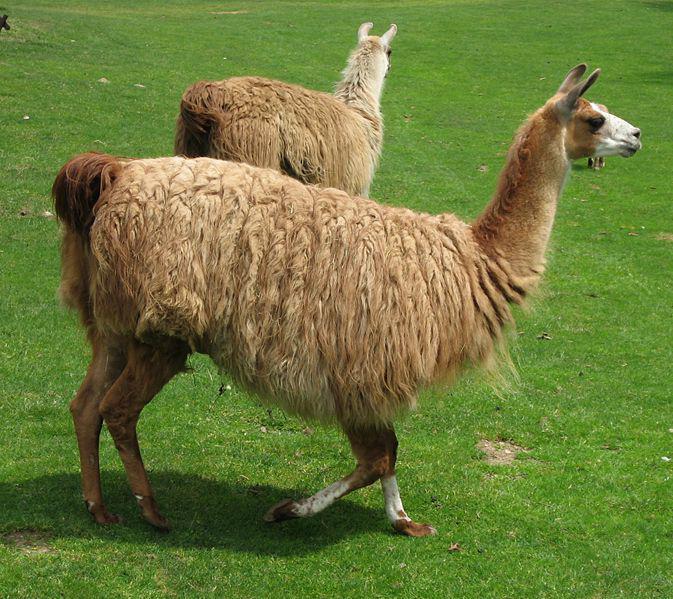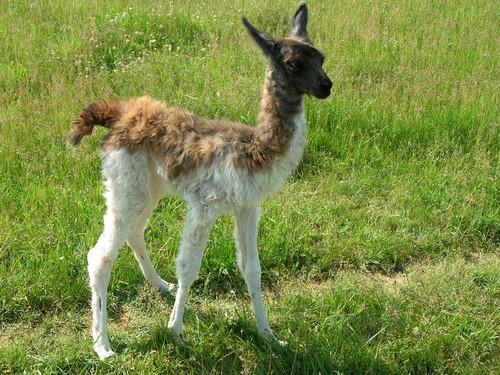The first image is the image on the left, the second image is the image on the right. Given the left and right images, does the statement "The left and right image contains the same number of llamas." hold true? Answer yes or no. No. The first image is the image on the left, the second image is the image on the right. Considering the images on both sides, is "There are exactly two llamas in total." valid? Answer yes or no. No. 